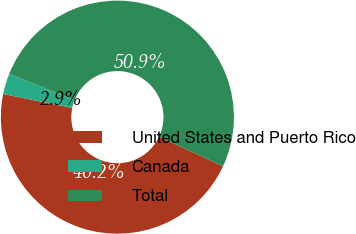Convert chart. <chart><loc_0><loc_0><loc_500><loc_500><pie_chart><fcel>United States and Puerto Rico<fcel>Canada<fcel>Total<nl><fcel>46.25%<fcel>2.87%<fcel>50.88%<nl></chart> 